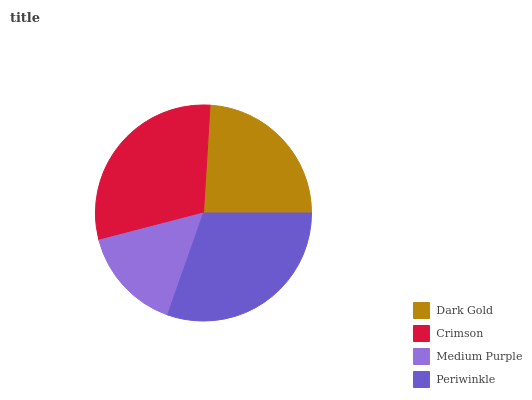Is Medium Purple the minimum?
Answer yes or no. Yes. Is Periwinkle the maximum?
Answer yes or no. Yes. Is Crimson the minimum?
Answer yes or no. No. Is Crimson the maximum?
Answer yes or no. No. Is Crimson greater than Dark Gold?
Answer yes or no. Yes. Is Dark Gold less than Crimson?
Answer yes or no. Yes. Is Dark Gold greater than Crimson?
Answer yes or no. No. Is Crimson less than Dark Gold?
Answer yes or no. No. Is Crimson the high median?
Answer yes or no. Yes. Is Dark Gold the low median?
Answer yes or no. Yes. Is Periwinkle the high median?
Answer yes or no. No. Is Periwinkle the low median?
Answer yes or no. No. 